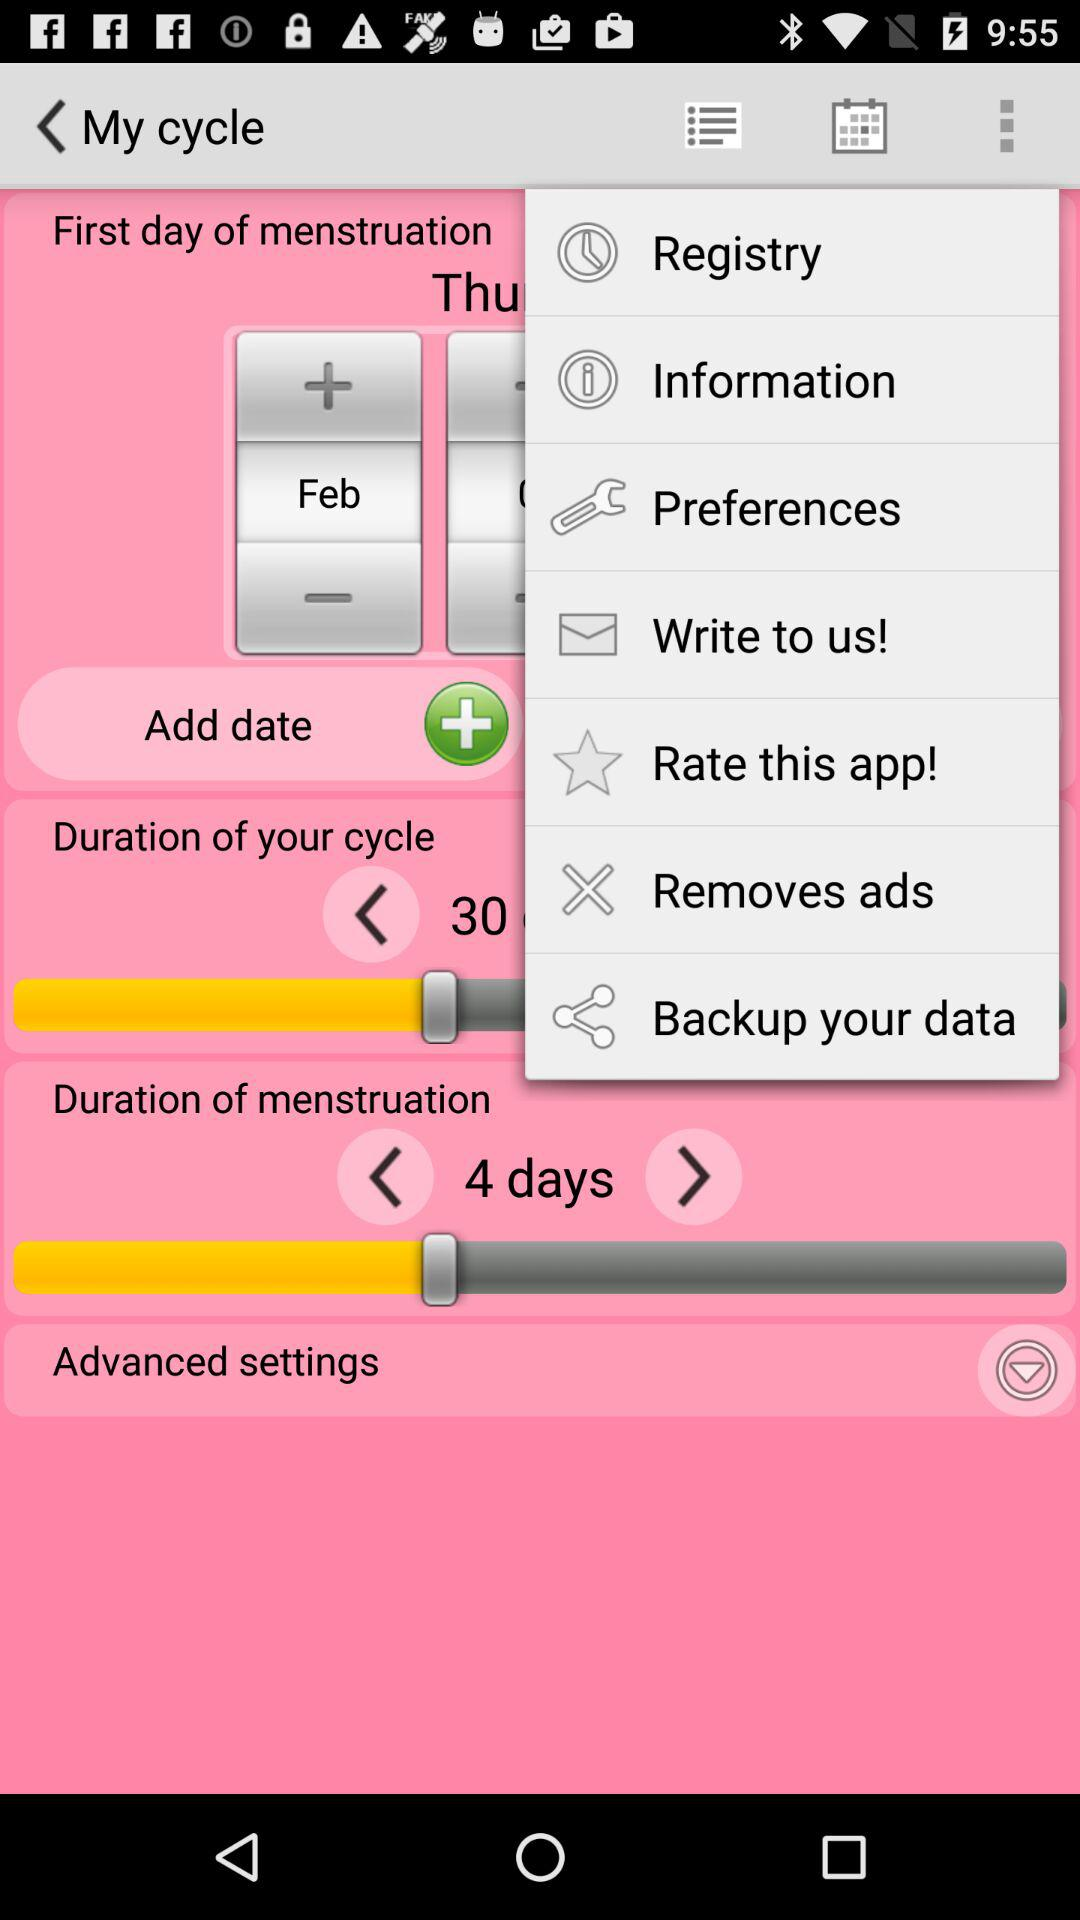How many days is the duration of the menstruation?
Answer the question using a single word or phrase. 4 days 